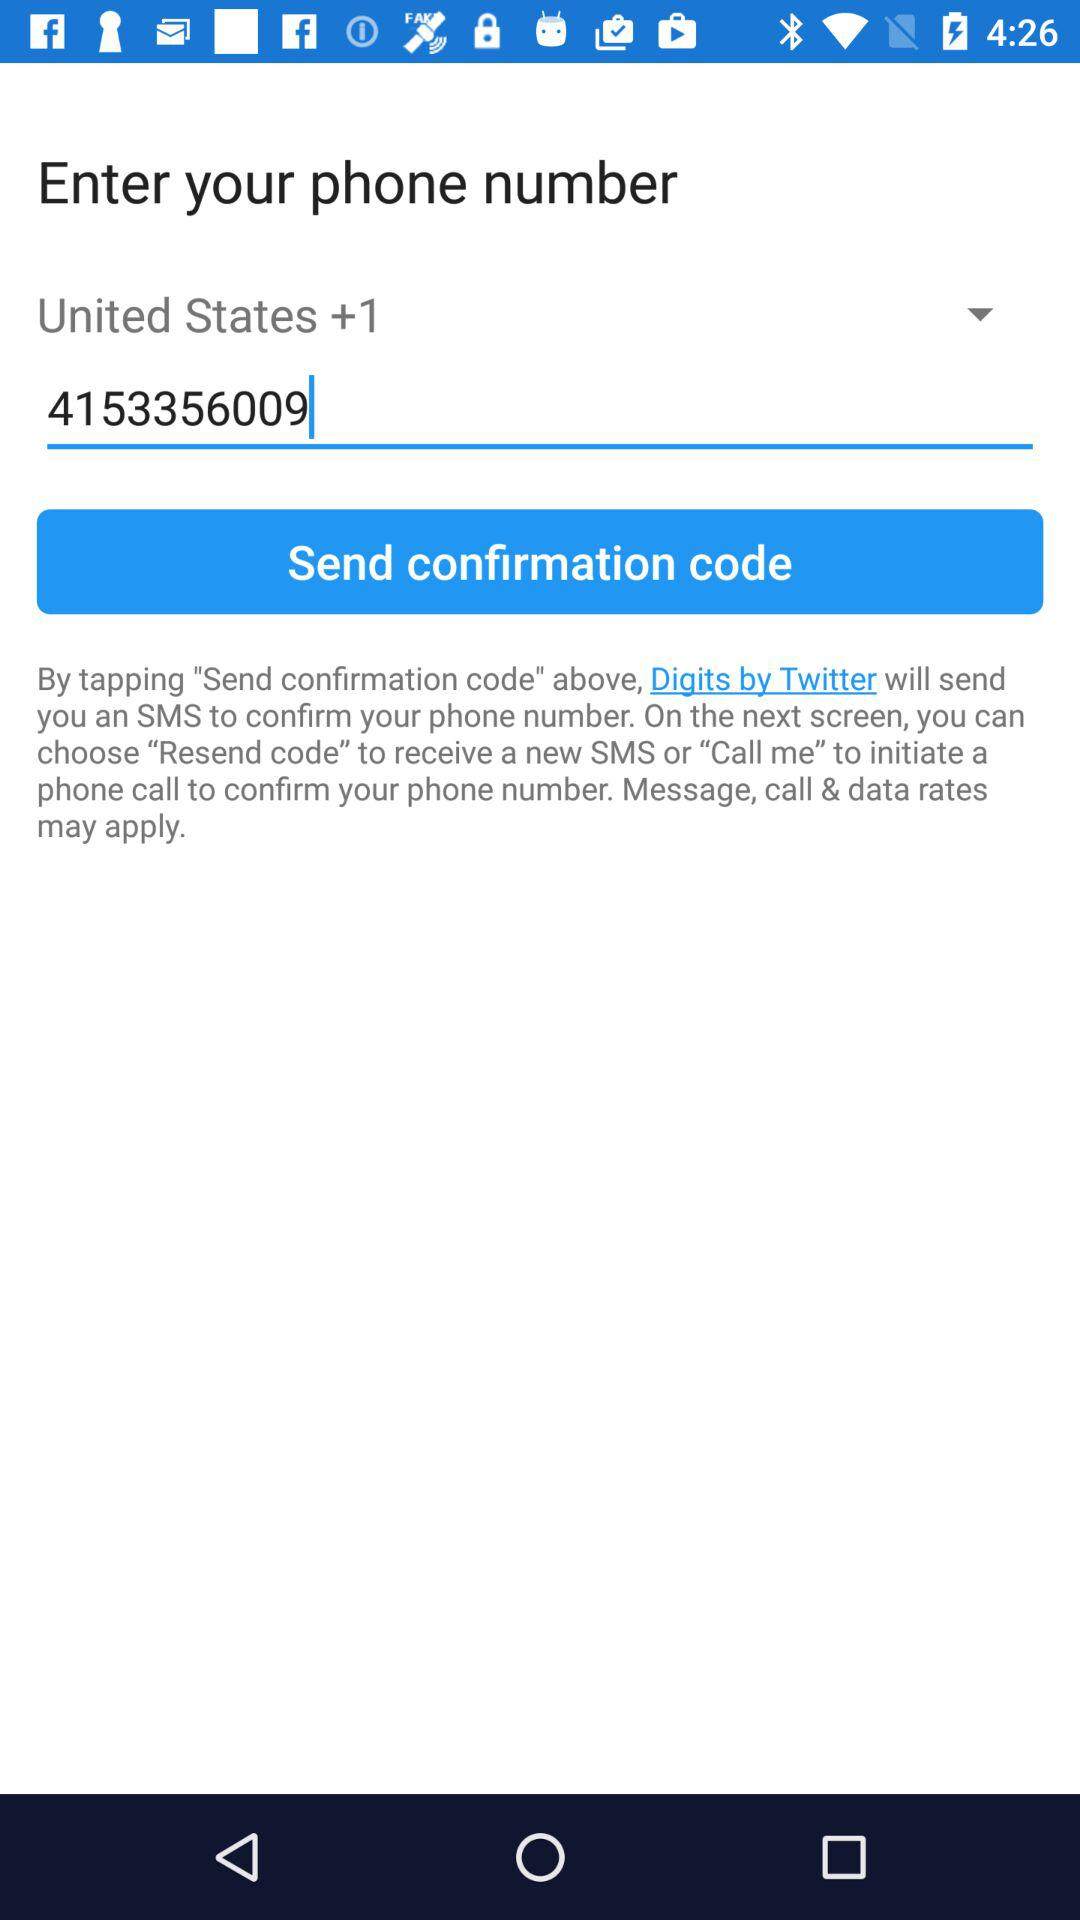Which country is selected? The selected country is United States. 